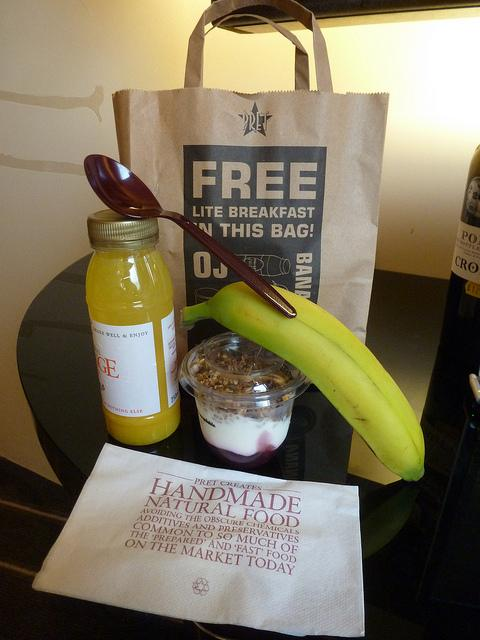What liquid have they been given for breakfast?

Choices:
A) banana juice
B) mango juice
C) pineapple juice
D) orange juice orange juice 